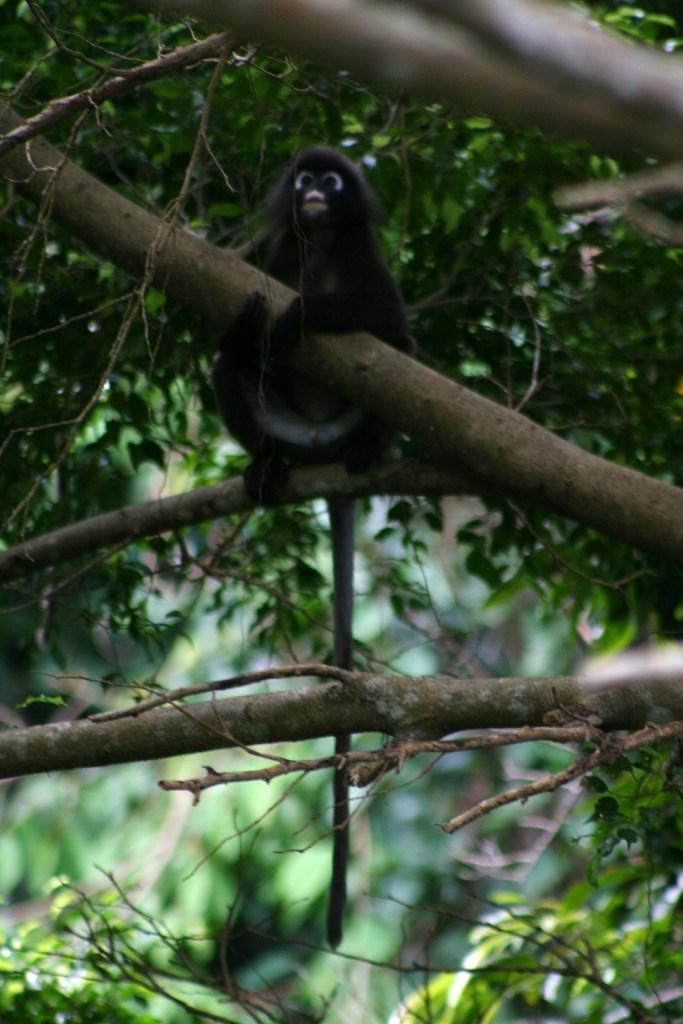What type of animal is in the image? The animal in the image is not specified, but it is present in the image. Where is the animal located in the image? The animal is on a tree branch in the image. What is the animal doing with the branch? The animal is holding a branch in the image. Can you describe the background of the image? The background of the image is blurred. What is the manager's relation to the animal in the image? There is no mention of a manager in the image or the facts provided, so it is not possible to determine any relation between the manager and the animal. 